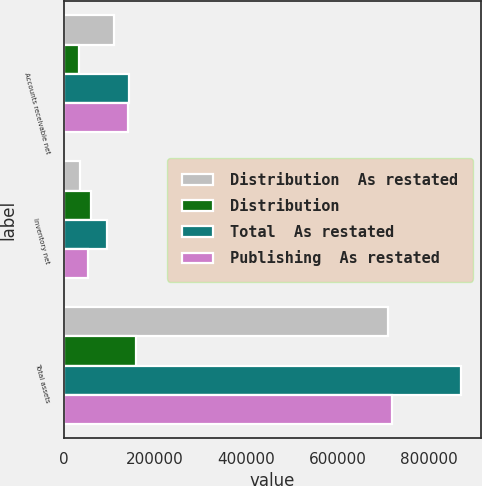Convert chart to OTSL. <chart><loc_0><loc_0><loc_500><loc_500><stacked_bar_chart><ecel><fcel>Accounts receivable net<fcel>Inventory net<fcel>Total assets<nl><fcel>Distribution  As restated<fcel>109974<fcel>35068<fcel>710467<nl><fcel>Distribution<fcel>33225<fcel>60452<fcel>158339<nl><fcel>Total  As restated<fcel>143199<fcel>95520<fcel>868806<nl><fcel>Publishing  As restated<fcel>140017<fcel>54149<fcel>717756<nl></chart> 